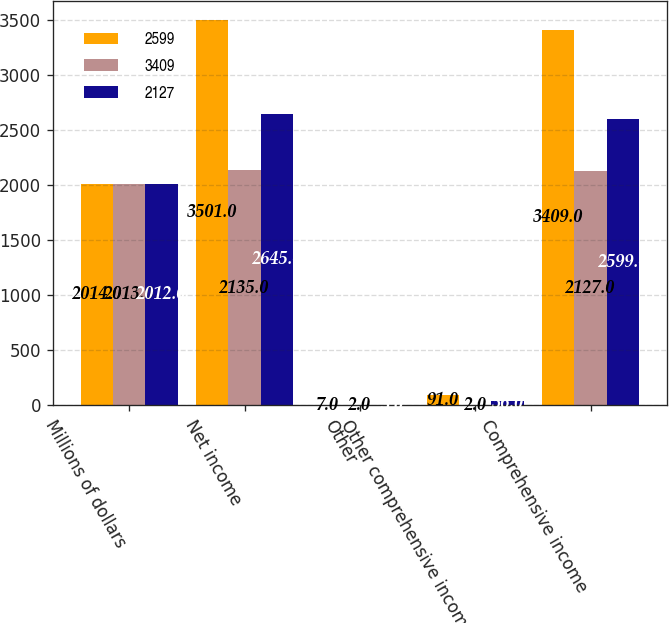Convert chart. <chart><loc_0><loc_0><loc_500><loc_500><stacked_bar_chart><ecel><fcel>Millions of dollars<fcel>Net income<fcel>Other<fcel>Other comprehensive income<fcel>Comprehensive income<nl><fcel>2599<fcel>2014<fcel>3501<fcel>7<fcel>91<fcel>3409<nl><fcel>3409<fcel>2013<fcel>2135<fcel>2<fcel>2<fcel>2127<nl><fcel>2127<fcel>2012<fcel>2645<fcel>3<fcel>36<fcel>2599<nl></chart> 